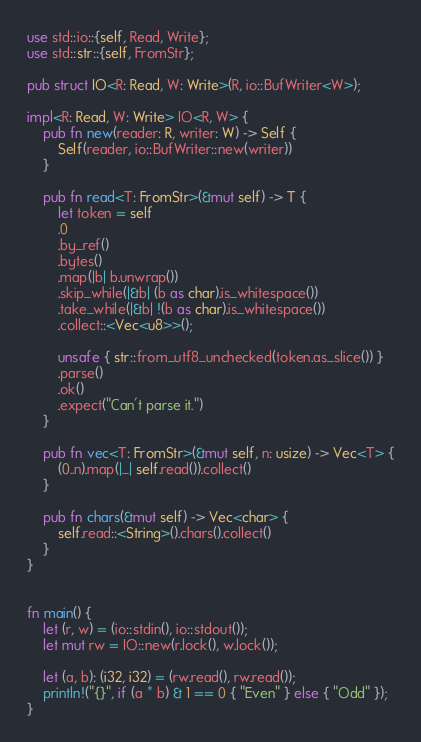Convert code to text. <code><loc_0><loc_0><loc_500><loc_500><_Rust_>use std::io::{self, Read, Write};
use std::str::{self, FromStr};

pub struct IO<R: Read, W: Write>(R, io::BufWriter<W>);

impl<R: Read, W: Write> IO<R, W> {
    pub fn new(reader: R, writer: W) -> Self {
        Self(reader, io::BufWriter::new(writer))
    }

    pub fn read<T: FromStr>(&mut self) -> T {
        let token = self
        .0
        .by_ref()
        .bytes()
        .map(|b| b.unwrap())
        .skip_while(|&b| (b as char).is_whitespace())
        .take_while(|&b| !(b as char).is_whitespace())
        .collect::<Vec<u8>>();

        unsafe { str::from_utf8_unchecked(token.as_slice()) }
        .parse()
        .ok()
        .expect("Can't parse it.")
    }

    pub fn vec<T: FromStr>(&mut self, n: usize) -> Vec<T> {
        (0..n).map(|_| self.read()).collect()
    }

    pub fn chars(&mut self) -> Vec<char> {
        self.read::<String>().chars().collect()
    }
}


fn main() {
    let (r, w) = (io::stdin(), io::stdout());
    let mut rw = IO::new(r.lock(), w.lock());

    let (a, b): (i32, i32) = (rw.read(), rw.read());
    println!("{}", if (a * b) & 1 == 0 { "Even" } else { "Odd" });
}</code> 